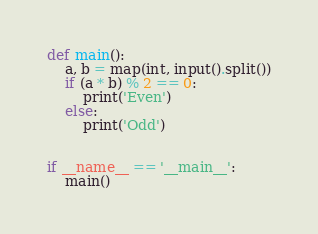<code> <loc_0><loc_0><loc_500><loc_500><_Python_>def main():
    a, b = map(int, input().split())
    if (a * b) % 2 == 0:
        print('Even')
    else:
        print('Odd')


if __name__ == '__main__':
    main()
</code> 